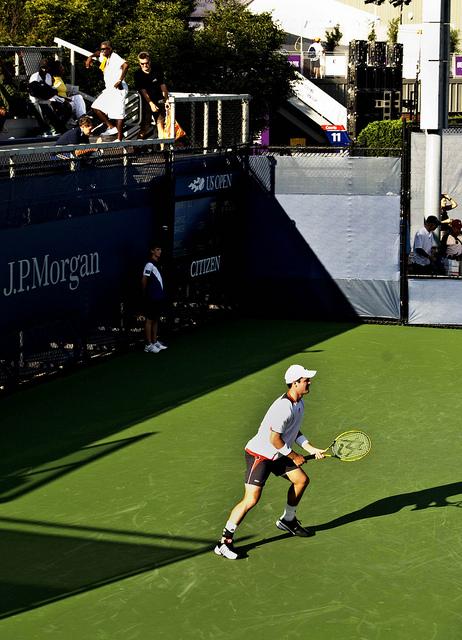What type of ground is the man playing tennis on?
Be succinct. Grass. What color are the stripes on the ground?
Short answer required. White. Is this man casting a shadow?
Concise answer only. Yes. In what hand is the man holding the tennis racket?
Be succinct. Right. What is the sign in the back?
Quick response, please. Jp morgan. What color is the tennis court?
Keep it brief. Green. What is the man in the center about to do?
Write a very short answer. Play tennis. 